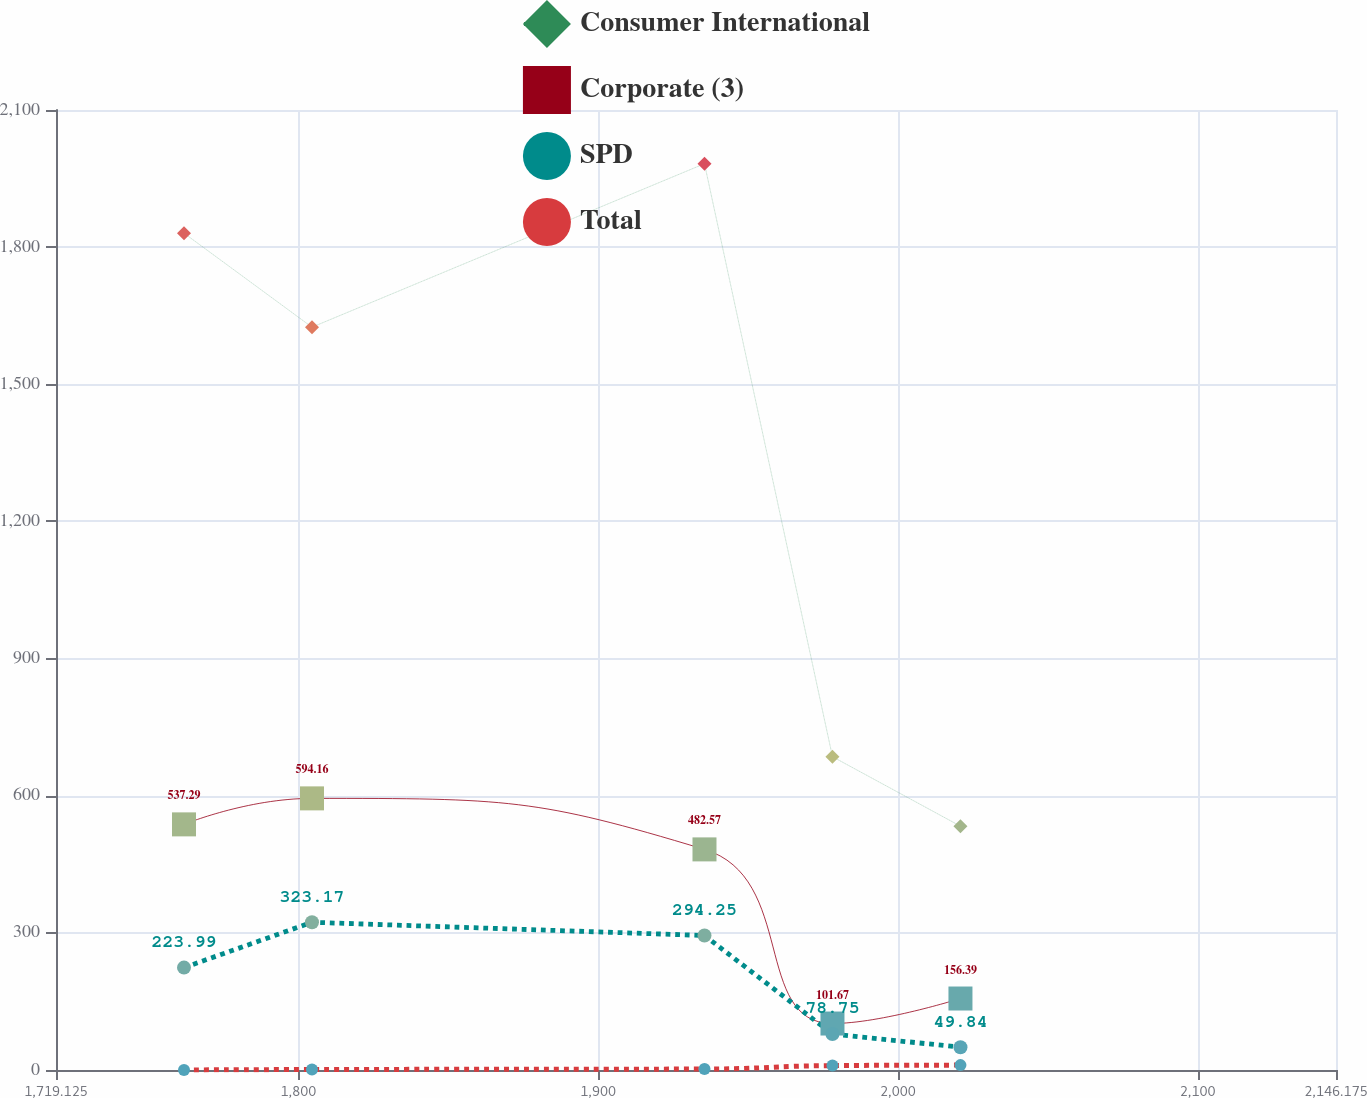<chart> <loc_0><loc_0><loc_500><loc_500><line_chart><ecel><fcel>Consumer International<fcel>Corporate (3)<fcel>SPD<fcel>Total<nl><fcel>1761.83<fcel>1830.58<fcel>537.29<fcel>223.99<fcel>0<nl><fcel>1804.53<fcel>1624.94<fcel>594.16<fcel>323.17<fcel>1.06<nl><fcel>1935.48<fcel>1982.55<fcel>482.57<fcel>294.25<fcel>2.12<nl><fcel>1978.18<fcel>685.33<fcel>101.67<fcel>78.75<fcel>9.62<nl><fcel>2020.88<fcel>533.36<fcel>156.39<fcel>49.84<fcel>10.68<nl><fcel>2188.88<fcel>381.39<fcel>46.95<fcel>20.93<fcel>4.96<nl></chart> 